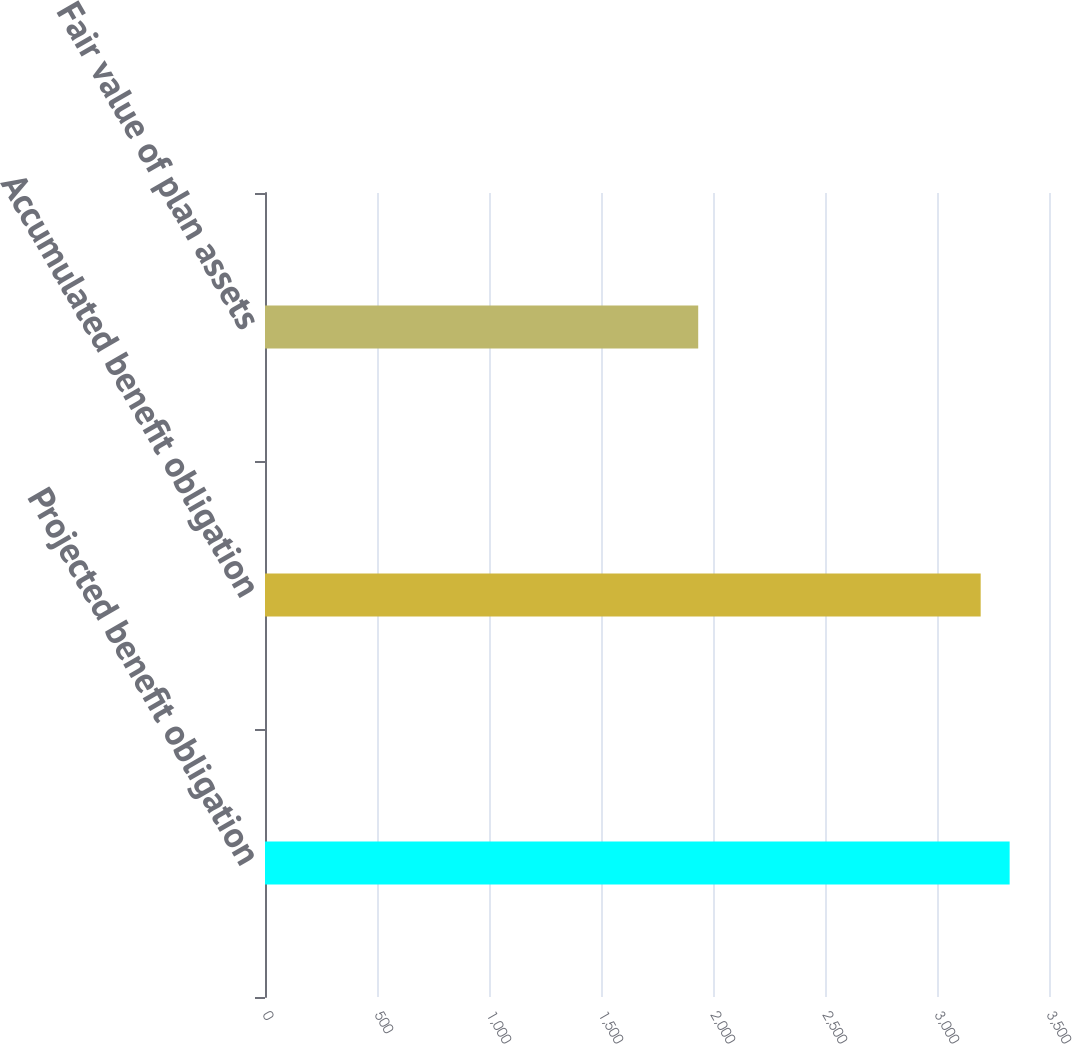Convert chart to OTSL. <chart><loc_0><loc_0><loc_500><loc_500><bar_chart><fcel>Projected benefit obligation<fcel>Accumulated benefit obligation<fcel>Fair value of plan assets<nl><fcel>3324.3<fcel>3195<fcel>1934<nl></chart> 